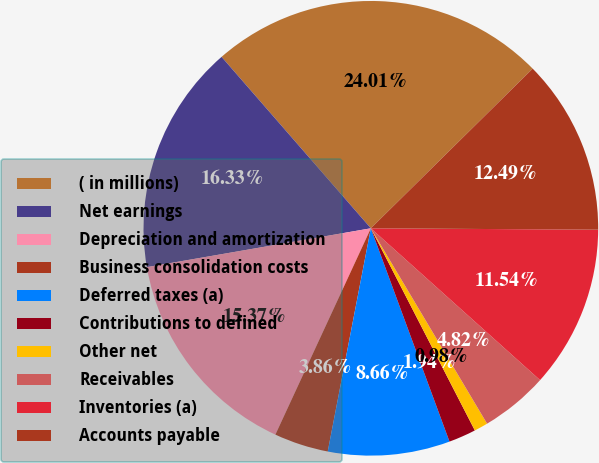Convert chart to OTSL. <chart><loc_0><loc_0><loc_500><loc_500><pie_chart><fcel>( in millions)<fcel>Net earnings<fcel>Depreciation and amortization<fcel>Business consolidation costs<fcel>Deferred taxes (a)<fcel>Contributions to defined<fcel>Other net<fcel>Receivables<fcel>Inventories (a)<fcel>Accounts payable<nl><fcel>24.01%<fcel>16.33%<fcel>15.37%<fcel>3.86%<fcel>8.66%<fcel>1.94%<fcel>0.98%<fcel>4.82%<fcel>11.54%<fcel>12.49%<nl></chart> 